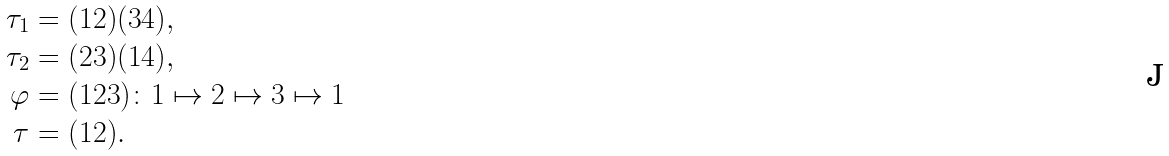<formula> <loc_0><loc_0><loc_500><loc_500>\tau _ { 1 } & = ( 1 2 ) ( 3 4 ) , \\ \tau _ { 2 } & = ( 2 3 ) ( 1 4 ) , \\ \varphi & = ( 1 2 3 ) \colon 1 \mapsto 2 \mapsto 3 \mapsto 1 \\ \tau & = ( 1 2 ) .</formula> 